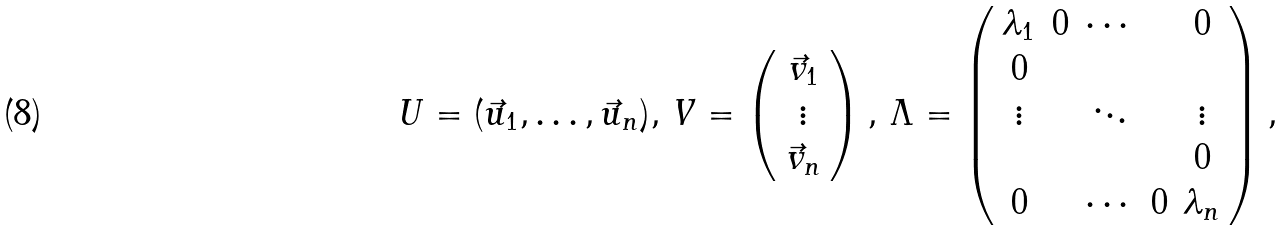Convert formula to latex. <formula><loc_0><loc_0><loc_500><loc_500>U = ( \vec { u } _ { 1 } , \dots , \vec { u } _ { n } ) , \, V = \left ( \begin{array} { c } \vec { v } _ { 1 } \\ \vdots \\ \vec { v } _ { n } \end{array} \right ) , \, \Lambda = \left ( \begin{array} { c c c c c } \lambda _ { 1 } & 0 & \cdots & & 0 \\ 0 & & & & \\ \vdots & & \ddots & & \vdots \\ & & & & 0 \\ 0 & & \cdots & 0 & \lambda _ { n } \end{array} \right ) ,</formula> 